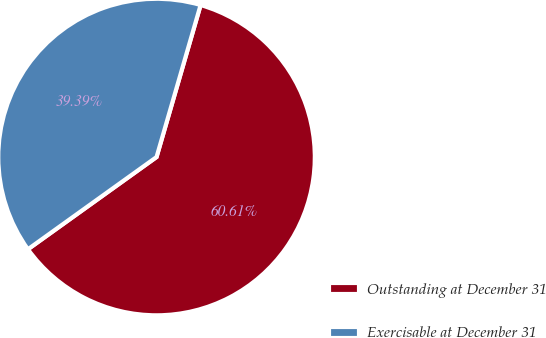Convert chart. <chart><loc_0><loc_0><loc_500><loc_500><pie_chart><fcel>Outstanding at December 31<fcel>Exercisable at December 31<nl><fcel>60.61%<fcel>39.39%<nl></chart> 